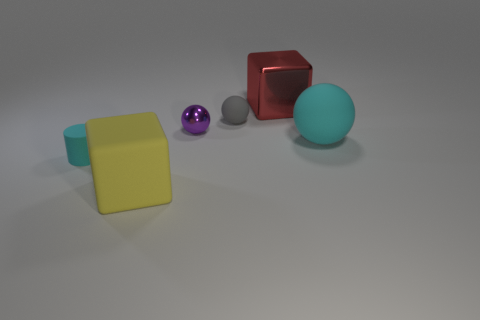There is a block that is behind the large thing to the left of the small purple shiny sphere; what size is it? The block positioned behind the larger red cube, which is to the left of the small purple shiny sphere, appears to be medium-sized compared to the other objects in the scene. 